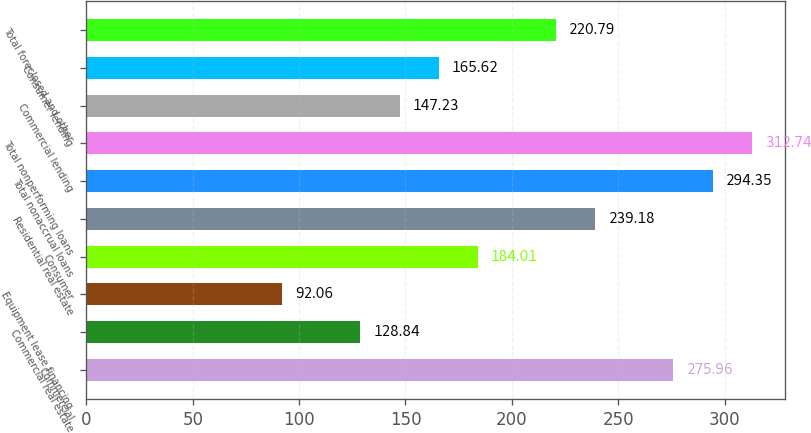Convert chart to OTSL. <chart><loc_0><loc_0><loc_500><loc_500><bar_chart><fcel>Commercial<fcel>Commercial real estate<fcel>Equipment lease financing<fcel>Consumer<fcel>Residential real estate<fcel>Total nonaccrual loans<fcel>Total nonperforming loans<fcel>Commercial lending<fcel>Consumer lending<fcel>Total foreclosed and other<nl><fcel>275.96<fcel>128.84<fcel>92.06<fcel>184.01<fcel>239.18<fcel>294.35<fcel>312.74<fcel>147.23<fcel>165.62<fcel>220.79<nl></chart> 